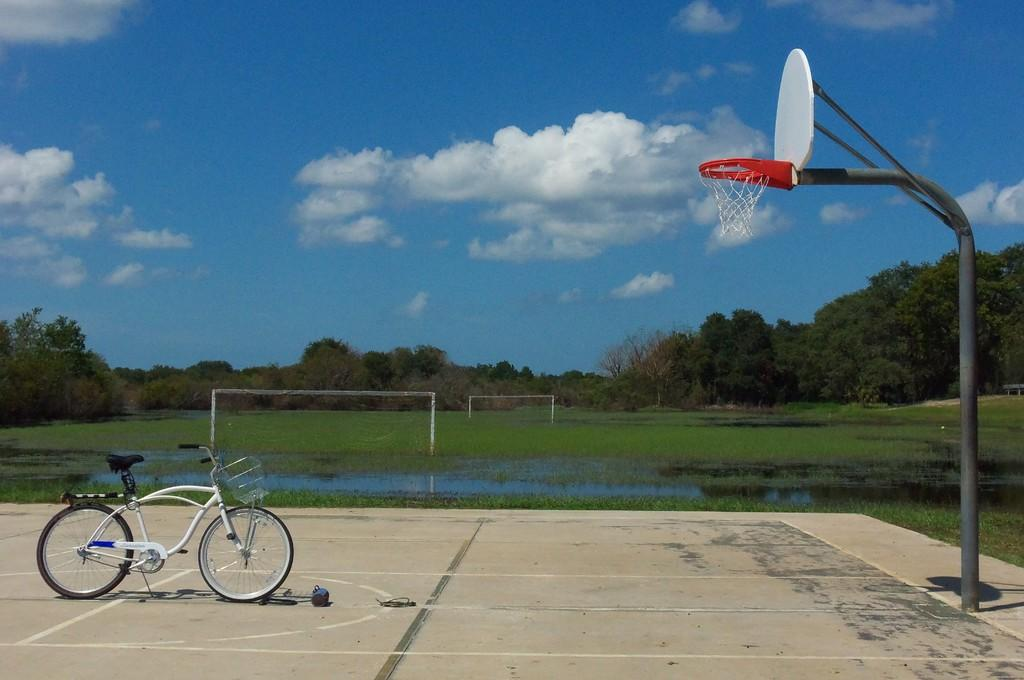What type of vehicle is in the image? There is a bicycle in the image. What type of sports equipment is in the image? There is a basketball in the image. What natural element is visible in the image? Water is visible in the image. What type of structure is in the image? There are nets in the image. What type of vegetation is in the image? There are trees and grass in the image. What part of the natural environment is visible in the image? The sky is visible in the image. What type of weather can be inferred from the image? Clouds are visible in the image, suggesting a partly cloudy day. What type of ship can be seen sailing in the water in the image? There is no ship present in the image; it features a bicycle, a basketball, water, nets, trees, grass, sky, and clouds. What type of amusement park ride is visible in the image? There is no amusement park ride present in the image; it features a bicycle, a basketball, water, nets, trees, grass, sky, and clouds. 